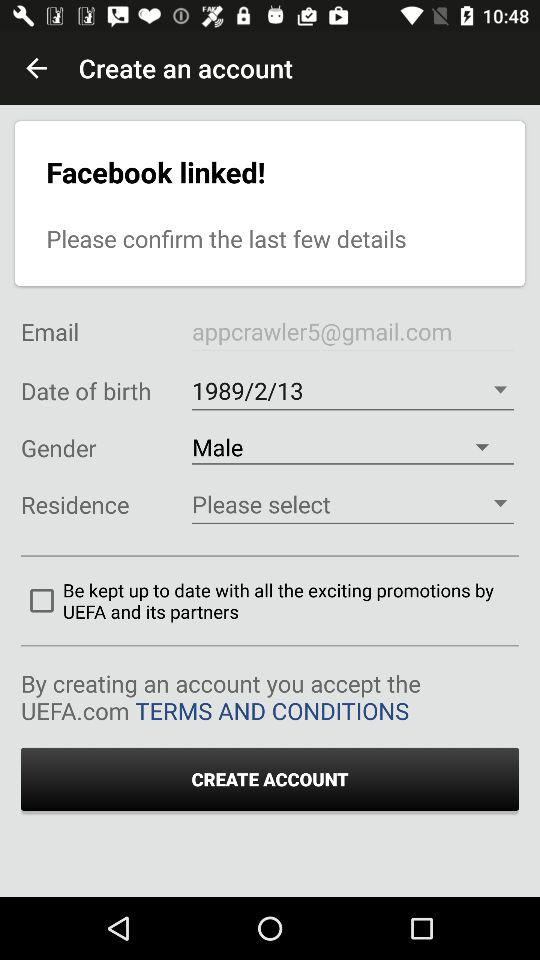What is the email address? The email address is appcrawler5@gmail.com. 